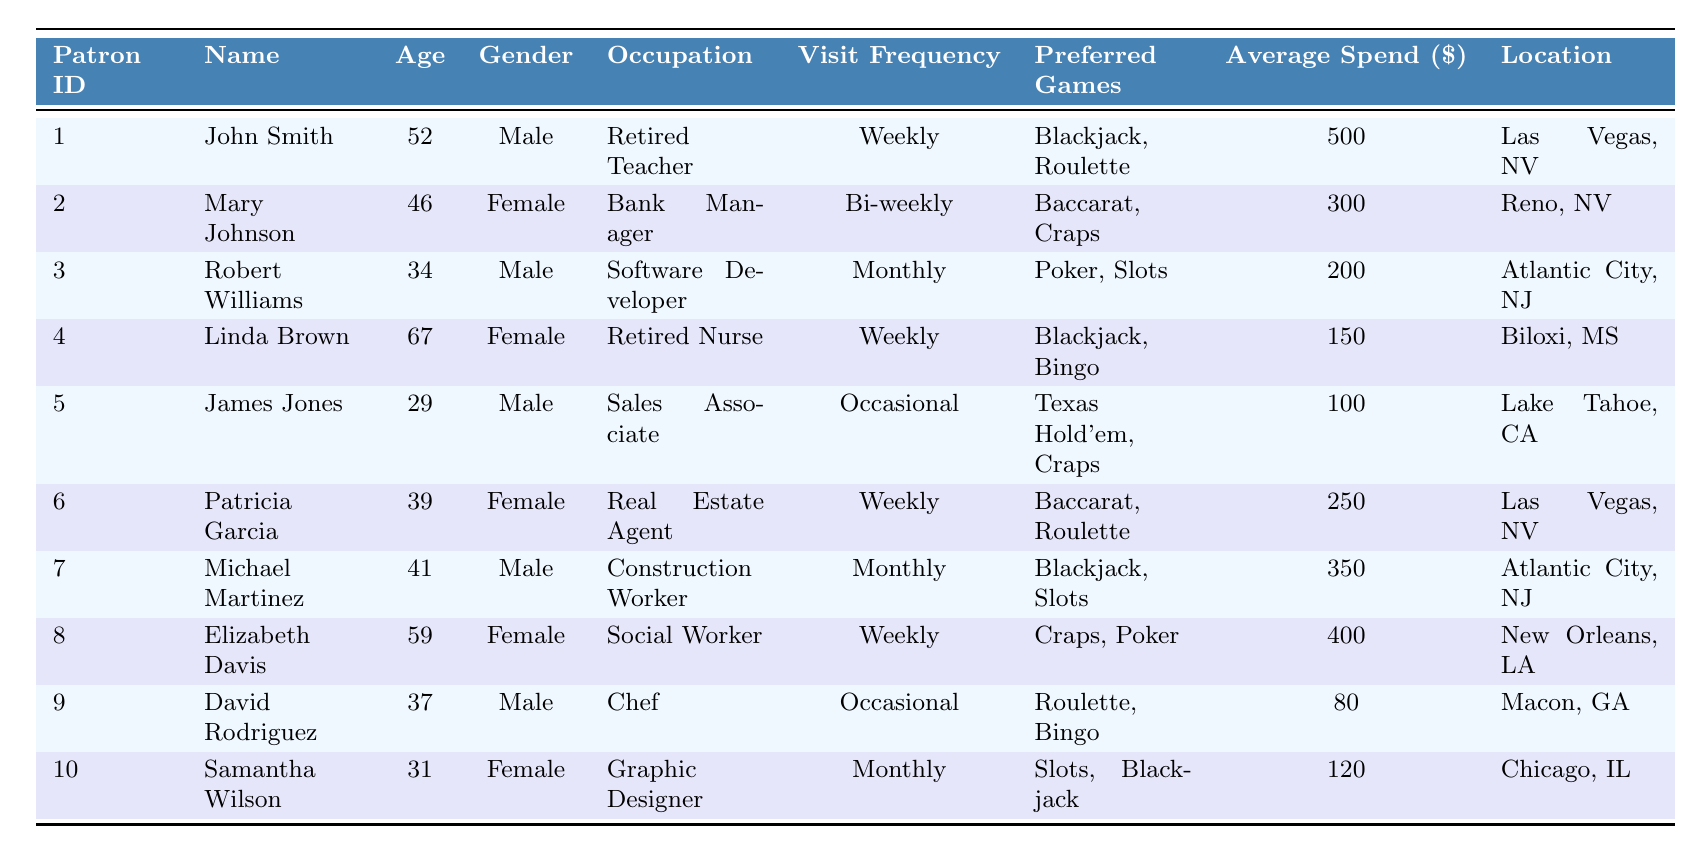What is the average age of casino patrons in the table? To find the average age, we first sum the ages of all patrons: (52 + 46 + 34 + 67 + 29 + 39 + 41 + 59 + 37 + 31) = 435. There are 10 patrons, so the average age is 435/10 = 43.5.
Answer: 43.5 How many patrons prefer Blackjack as one of their games? By scanning the data, we see that John Smith, Linda Brown, Michael Martinez, and Samantha Wilson all have Blackjack listed as a preferred game, totaling 4 patrons.
Answer: 4 Which patron has the highest average spend? Reviewing the average spend column, John Smith has the highest average spend of $500.
Answer: John Smith Is there a patron who visits the casino more than once a week? The visit frequency for all patrons indicates that none visit more than once a week; hence the answer is no.
Answer: No What is the total average spend of patrons who visit weekly? The patrons who visit weekly are John Smith, Linda Brown, Patricia Garcia, and Elizabeth Davis. Their average spends are $500, $150, $250, and $400 respectively. Summing them gives $500 + $150 + $250 + $400 = $1300. The total average spend for these 4 patrons is $1300/4 = $325.
Answer: 325 How many female patrons prefer Craps? Only Mary Johnson and Elizabeth Davis prefer Craps, giving a total of 2 female patrons who have Craps as a preferred game.
Answer: 2 Who is the youngest patron among those who visit monthly? The patrons visiting monthly are Robert Williams, Michael Martinez, and Samantha Wilson, aged 34, 41, and 31 respectively. The youngest among these is Samantha Wilson at age 31.
Answer: Samantha Wilson Is there a patron with the title of "Retired"? John Smith and Linda Brown are both retired; thus, there are two patrons with the title of "Retired."
Answer: Yes What is the total average spend of all patrons from Las Vegas? The patrons from Las Vegas are John Smith and Patricia Garcia, with average spends of $500 and $250 respectively. Adding these gives $500 + $250 = $750. The average spend for these 2 patrons is $750/2 = $375.
Answer: 375 Which patron's visit frequency is the least common in the dataset? By assessing the visit frequency, "Occasional" is exhibited by James Jones and David Rodriguez, making it the least common frequency with only two patrons.
Answer: Occasional 